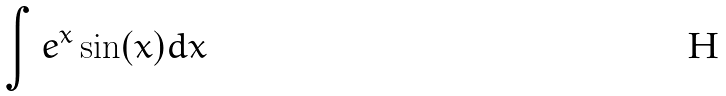Convert formula to latex. <formula><loc_0><loc_0><loc_500><loc_500>\int e ^ { x } \sin ( x ) d x</formula> 